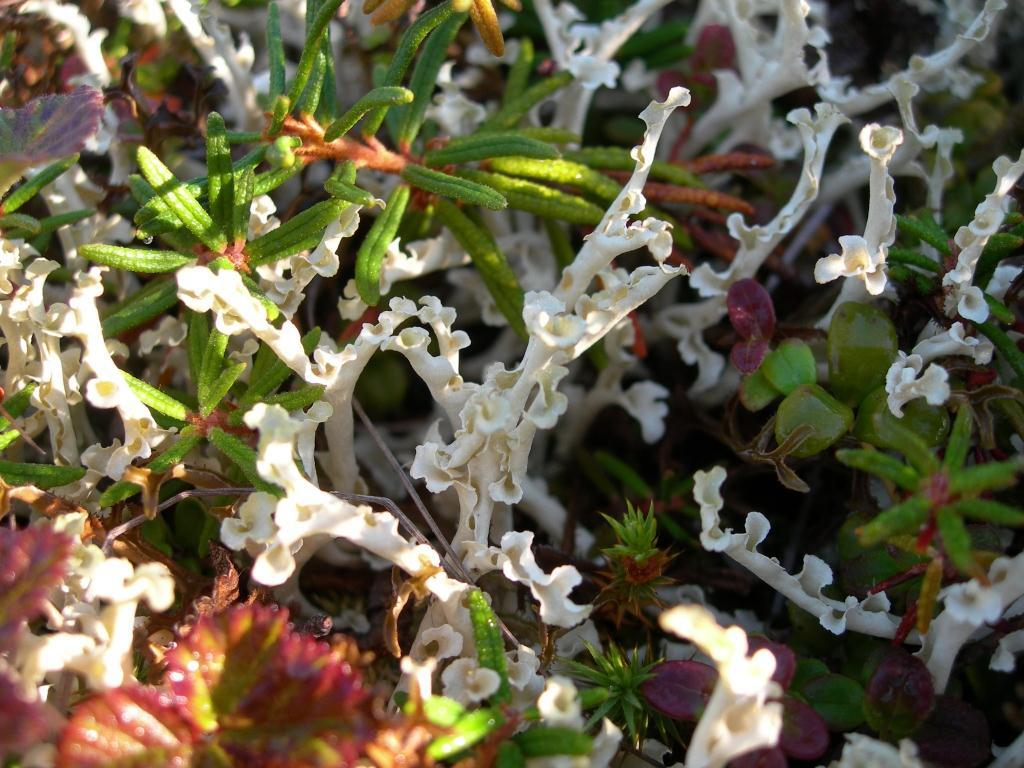What type of living organisms can be seen in the image? Plants can be seen in the image. What idea does the wall in the image represent? There is no wall present in the image, so it is not possible to determine what idea it might represent. 